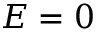Convert formula to latex. <formula><loc_0><loc_0><loc_500><loc_500>E = 0</formula> 